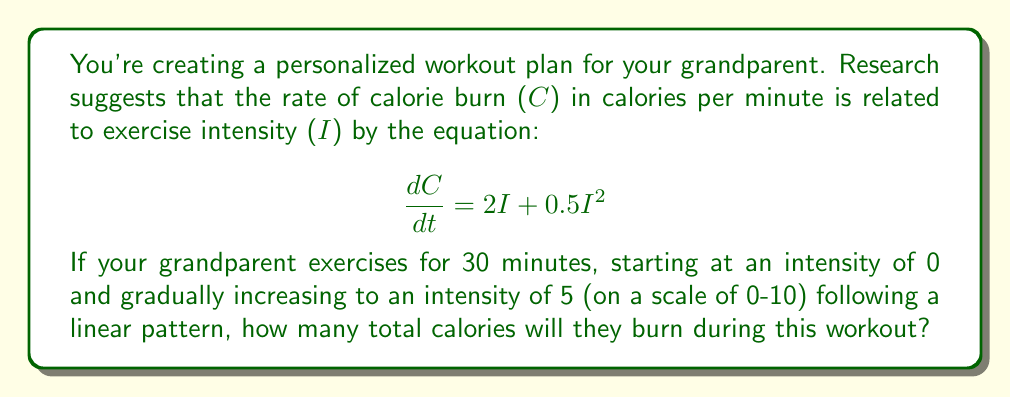Could you help me with this problem? Let's approach this step-by-step:

1) First, we need to express intensity (I) as a function of time (t). Given that it increases linearly from 0 to 5 over 30 minutes, we can write:

   $$I(t) = \frac{5t}{30} = \frac{t}{6}$$

2) Now, we can substitute this into our calorie burn rate equation:

   $$\frac{dC}{dt} = 2(\frac{t}{6}) + 0.5(\frac{t}{6})^2 = \frac{t}{3} + \frac{t^2}{72}$$

3) To find the total calories burned, we need to integrate this rate over the 30-minute period:

   $$C = \int_0^{30} (\frac{t}{3} + \frac{t^2}{72}) dt$$

4) Let's solve this integral:

   $$C = [\frac{t^2}{6} + \frac{t^3}{216}]_0^{30}$$

5) Evaluating at the limits:

   $$C = (\frac{30^2}{6} + \frac{30^3}{216}) - (0 + 0)$$

6) Simplifying:

   $$C = 150 + 125 = 275$$

Therefore, your grandparent will burn 275 calories during this 30-minute workout.
Answer: 275 calories 